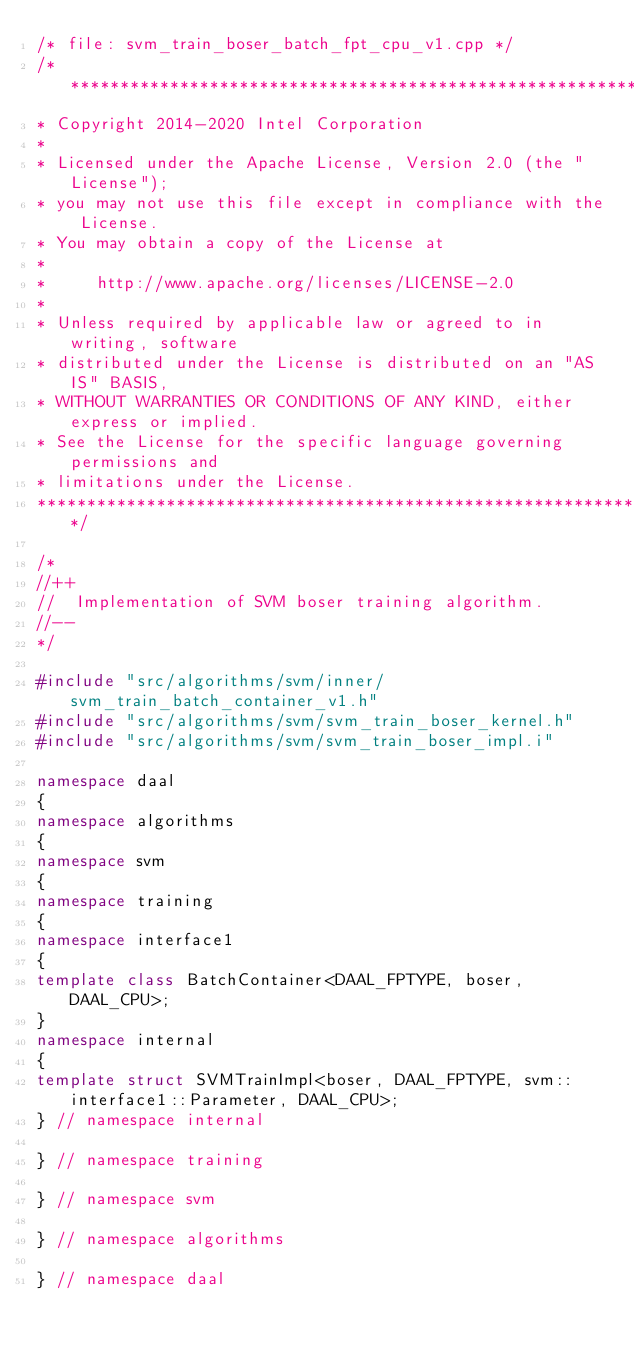Convert code to text. <code><loc_0><loc_0><loc_500><loc_500><_C++_>/* file: svm_train_boser_batch_fpt_cpu_v1.cpp */
/*******************************************************************************
* Copyright 2014-2020 Intel Corporation
*
* Licensed under the Apache License, Version 2.0 (the "License");
* you may not use this file except in compliance with the License.
* You may obtain a copy of the License at
*
*     http://www.apache.org/licenses/LICENSE-2.0
*
* Unless required by applicable law or agreed to in writing, software
* distributed under the License is distributed on an "AS IS" BASIS,
* WITHOUT WARRANTIES OR CONDITIONS OF ANY KIND, either express or implied.
* See the License for the specific language governing permissions and
* limitations under the License.
*******************************************************************************/

/*
//++
//  Implementation of SVM boser training algorithm.
//--
*/

#include "src/algorithms/svm/inner/svm_train_batch_container_v1.h"
#include "src/algorithms/svm/svm_train_boser_kernel.h"
#include "src/algorithms/svm/svm_train_boser_impl.i"

namespace daal
{
namespace algorithms
{
namespace svm
{
namespace training
{
namespace interface1
{
template class BatchContainer<DAAL_FPTYPE, boser, DAAL_CPU>;
}
namespace internal
{
template struct SVMTrainImpl<boser, DAAL_FPTYPE, svm::interface1::Parameter, DAAL_CPU>;
} // namespace internal

} // namespace training

} // namespace svm

} // namespace algorithms

} // namespace daal
</code> 